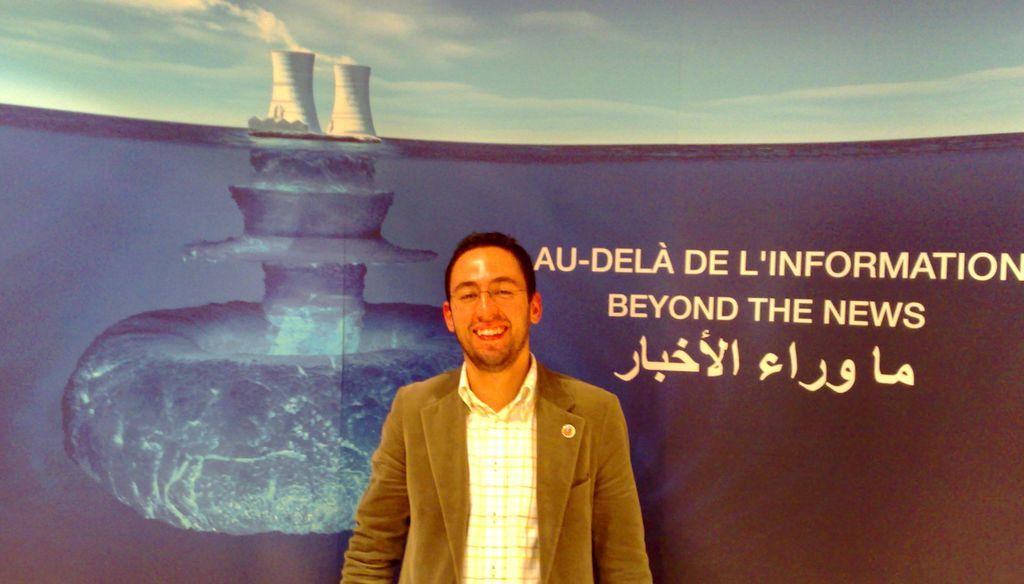What is the main subject of the image? There is a man standing in the image. Can you describe the man's appearance? The man is wearing spectacles, a coat, and a shirt. What can be seen in the background of the image? There is sky and text visible in the background of the image. How many crows are sitting on the man's shoulder in the image? There are no crows present in the image. What type of trouble is the man facing in the image? There is no indication of trouble in the image; it simply shows a man standing with specific clothing and background elements. 